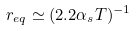<formula> <loc_0><loc_0><loc_500><loc_500>r _ { e q } \simeq ( 2 . 2 \alpha _ { s } T ) ^ { - 1 }</formula> 